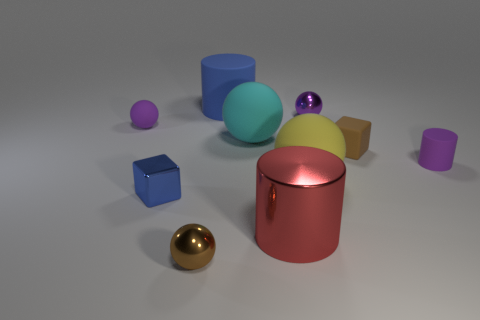How many cylinders are tiny purple objects or large yellow objects?
Give a very brief answer. 1. What number of other yellow spheres have the same material as the yellow ball?
Keep it short and to the point. 0. There is a metal thing that is the same color as the matte cube; what shape is it?
Provide a succinct answer. Sphere. The purple thing that is right of the small blue thing and left of the small brown rubber cube is made of what material?
Give a very brief answer. Metal. The purple matte object that is in front of the small rubber sphere has what shape?
Provide a succinct answer. Cylinder. What is the shape of the small brown object in front of the tiny brown thing that is on the right side of the small brown metallic thing?
Your response must be concise. Sphere. Is there a tiny brown rubber object of the same shape as the small blue object?
Keep it short and to the point. Yes. The other metal thing that is the same size as the yellow thing is what shape?
Ensure brevity in your answer.  Cylinder. Are there any tiny purple shiny balls that are in front of the tiny purple matte object to the left of the rubber cylinder right of the large blue rubber cylinder?
Provide a short and direct response. No. Is there another yellow ball that has the same size as the yellow matte sphere?
Your answer should be compact. No. 